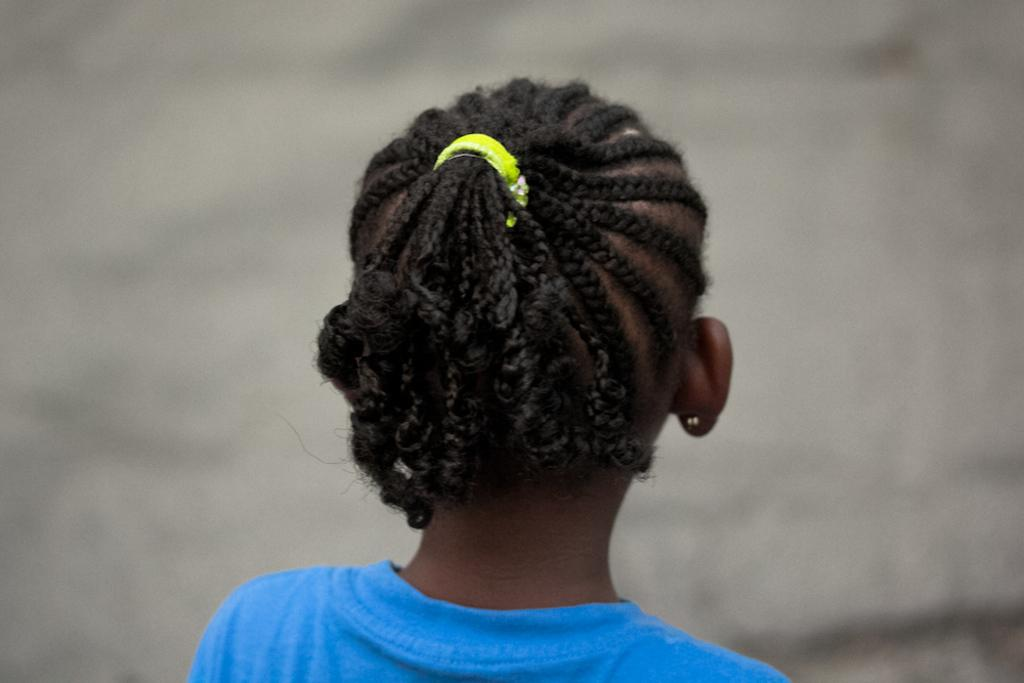What is the main subject of the image? The main subject of the image is a kid. What is the kid wearing in the image? The kid is wearing a blue t-shirt in the image. How many chickens are present in the image? There are no chickens present in the image; it features a kid wearing a blue t-shirt. What type of rabbits can be seen in the image? There are no rabbits present in the image. 